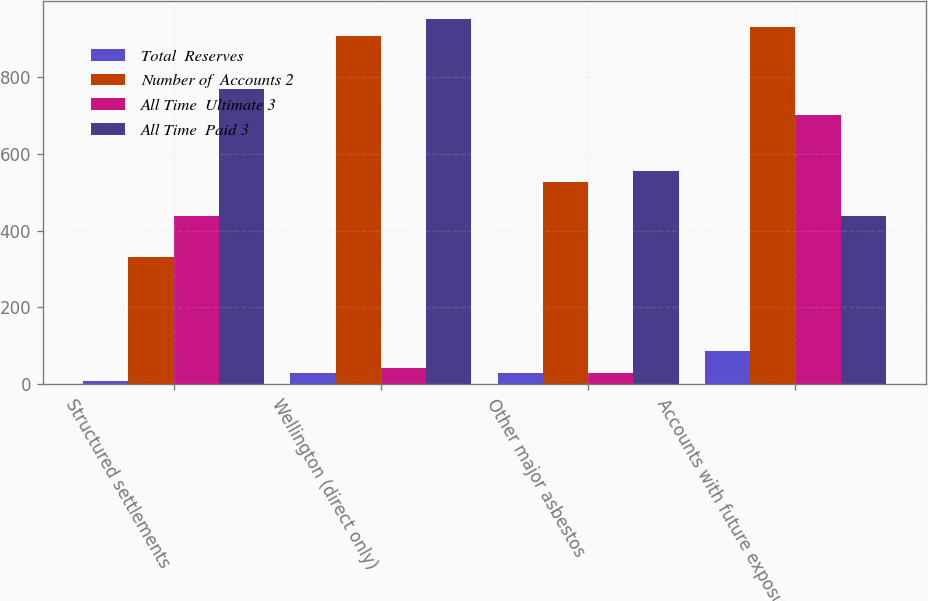Convert chart. <chart><loc_0><loc_0><loc_500><loc_500><stacked_bar_chart><ecel><fcel>Structured settlements<fcel>Wellington (direct only)<fcel>Other major asbestos<fcel>Accounts with future exposure<nl><fcel>Total  Reserves<fcel>8<fcel>29<fcel>28<fcel>85<nl><fcel>Number of  Accounts 2<fcel>331<fcel>908<fcel>527<fcel>929<nl><fcel>All Time  Ultimate 3<fcel>438<fcel>43<fcel>28<fcel>702<nl><fcel>All Time  Paid 3<fcel>769<fcel>951<fcel>555<fcel>438<nl></chart> 